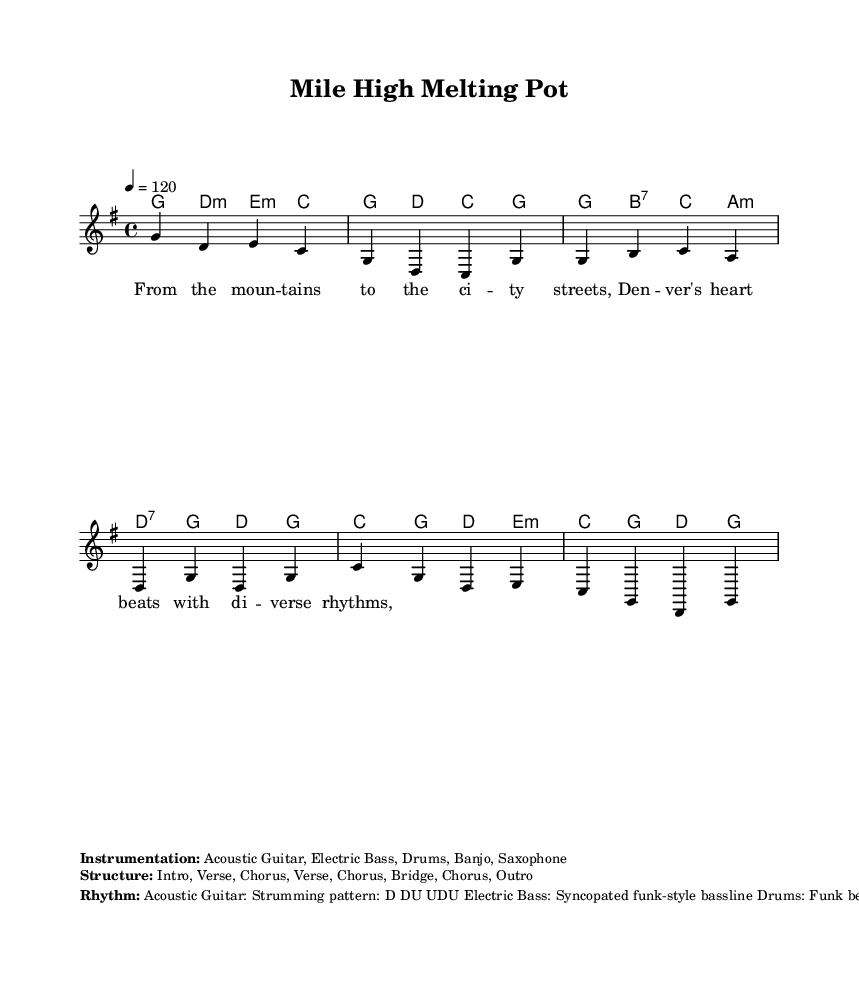What is the key signature of this music? The key signature is G major, which has one sharp (F#). You can tell from the global section of the code where the key is set with "\key g \major."
Answer: G major What is the time signature of the piece? The time signature is 4/4, which indicated that there are four beats in each measure. This is present in the global section where it is stated as "\time 4/4."
Answer: 4/4 What is the tempo of the piece? The tempo is set at 120 beats per minute, as indicated in the global settings with "\tempo 4 = 120." This means it is a moderate tempo, often used for lively pieces.
Answer: 120 How many sections does the music structure have? The structure consists of eight sections: Intro, Verse, Chorus, Verse, Chorus, Bridge, Chorus, and Outro. This is laid out in the markup section as "Structure: Intro, Verse, Chorus, Verse, Chorus, Bridge, Chorus, Outro."
Answer: Eight What instruments are featured in this piece? The instrumentation includes Acoustic Guitar, Electric Bass, Drums, Banjo, and Saxophone. This is listed in the markup's "Instrumentation" section detailing the different instruments used in this fusion piece.
Answer: Acoustic Guitar, Electric Bass, Drums, Banjo, Saxophone What type of bassline is used in this piece? The bassline is described as a syncopated funk-style bassline, which means it emphasizes off-beats, creating a groove typical of funk music. This is noted in the rhythm section of the markup.
Answer: Syncopated funk-style bassline What is the main theme of the lyrics in the verse? The main theme of the lyrics centers around the diversity of cultures in Denver, describing how the city's heart beats with diverse rhythms from the mountains to the city streets. This is derived from the content of the verse words provided.
Answer: Denver's diverse rhythms 